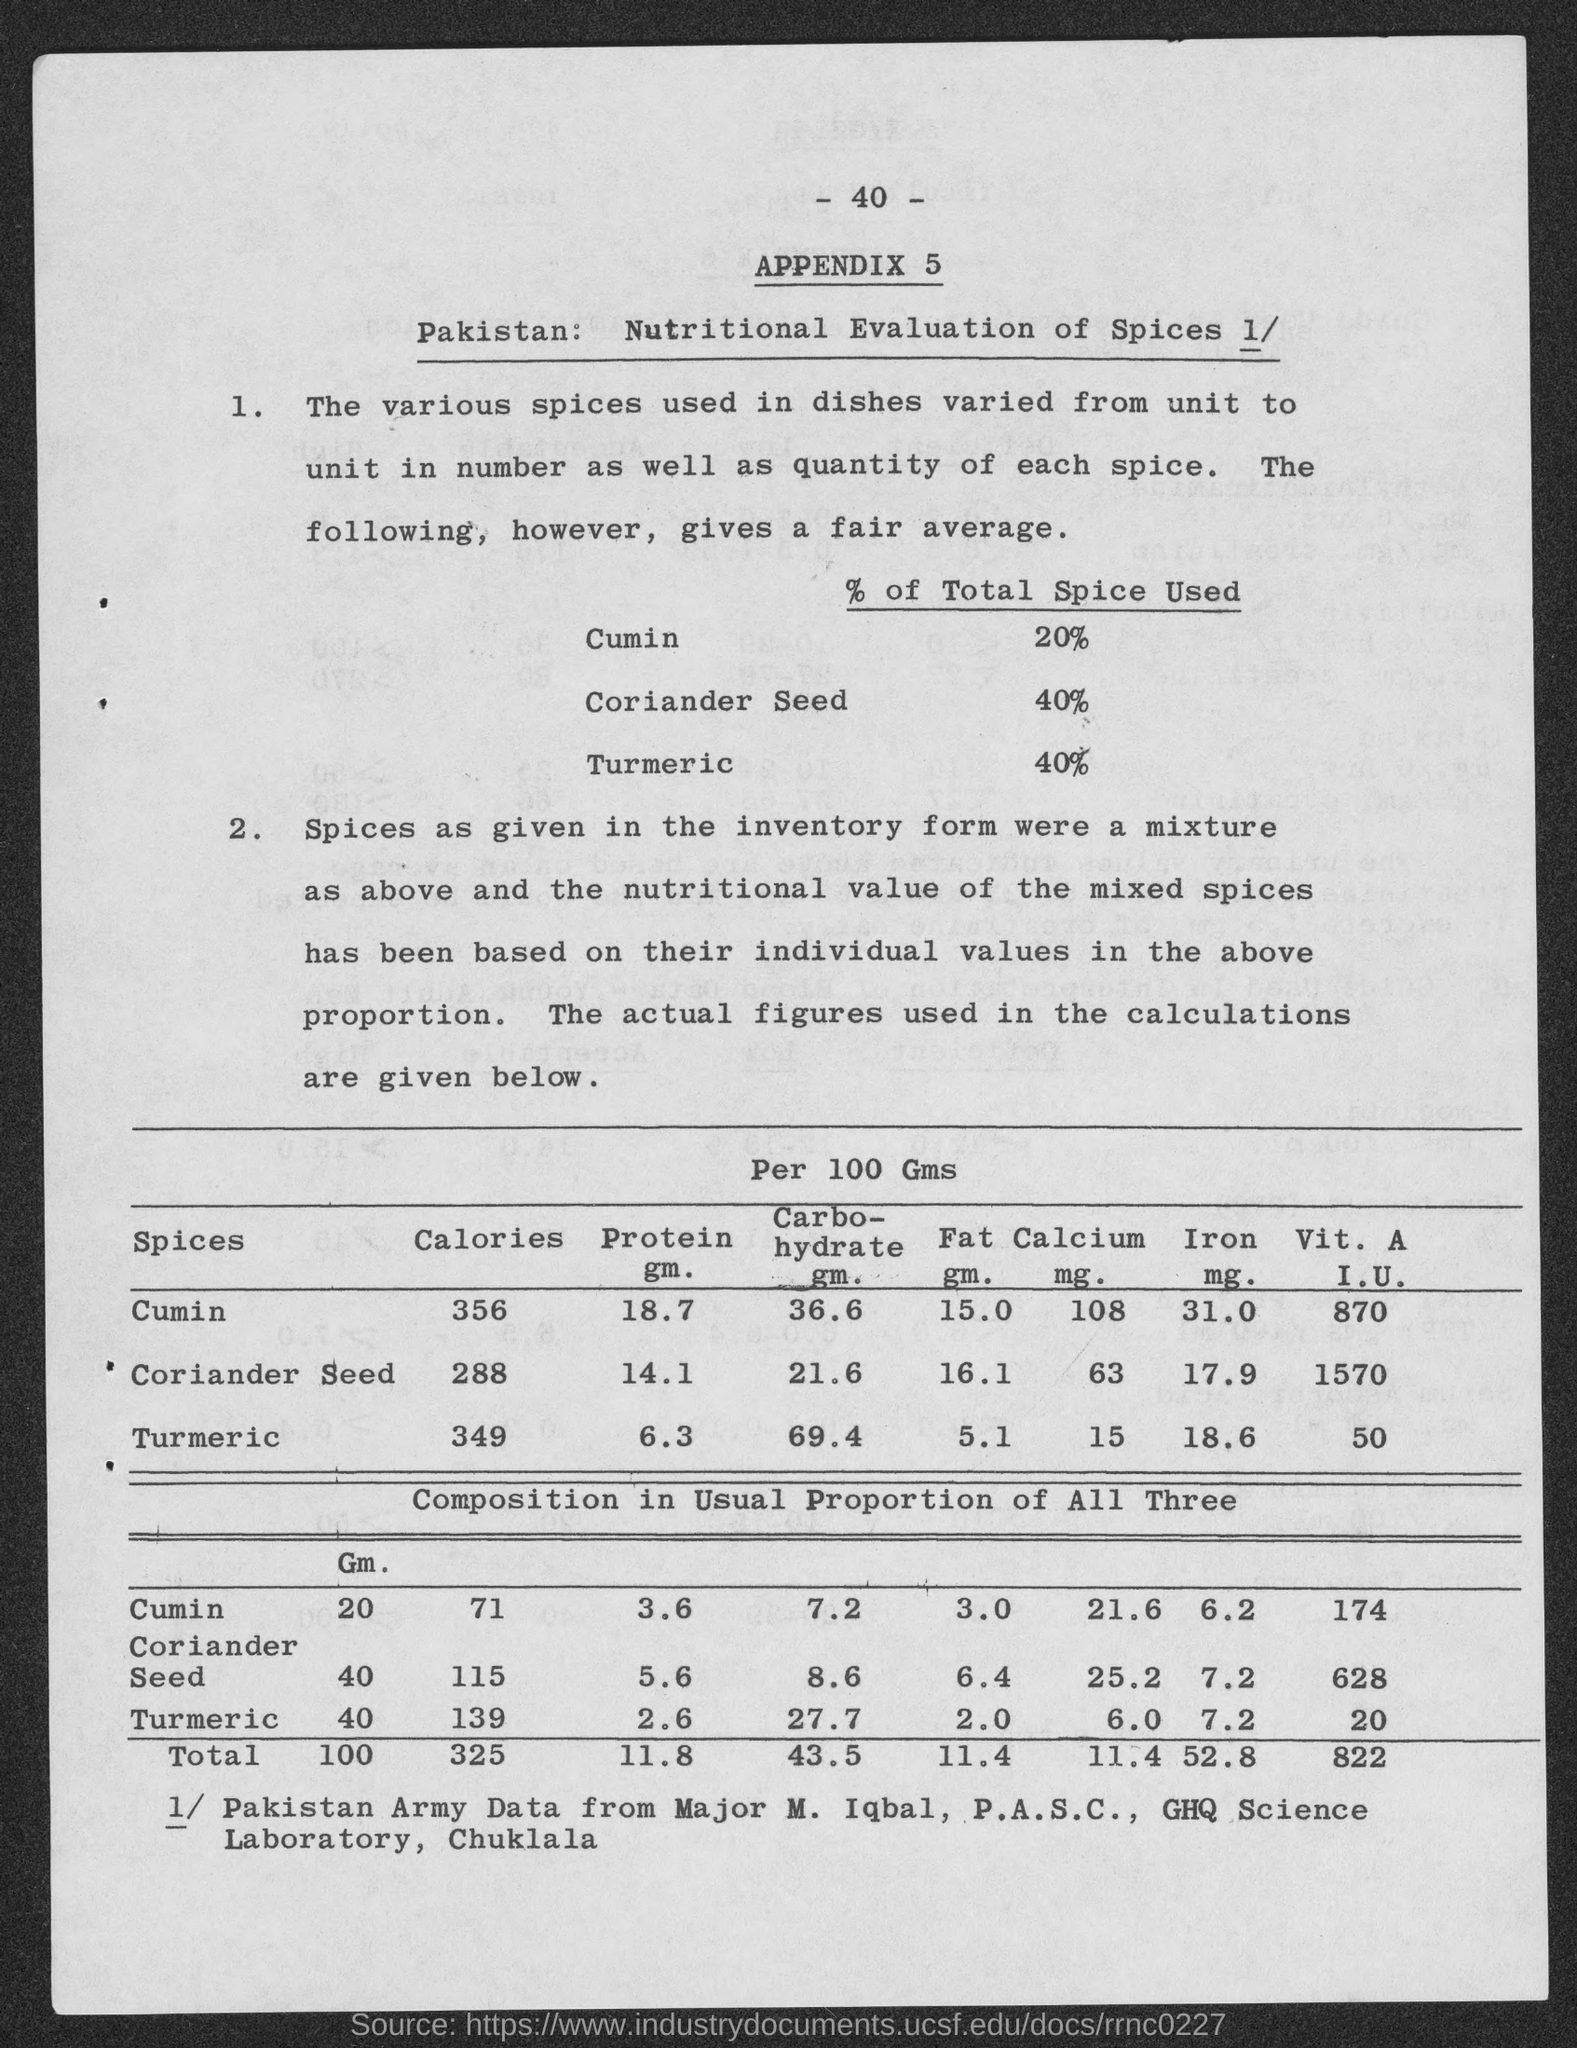what is the number at top of the page? The number at the top of the page is 40, which appears to be part of a page numbering system in a report or document titled 'APPENDIX 5'. 